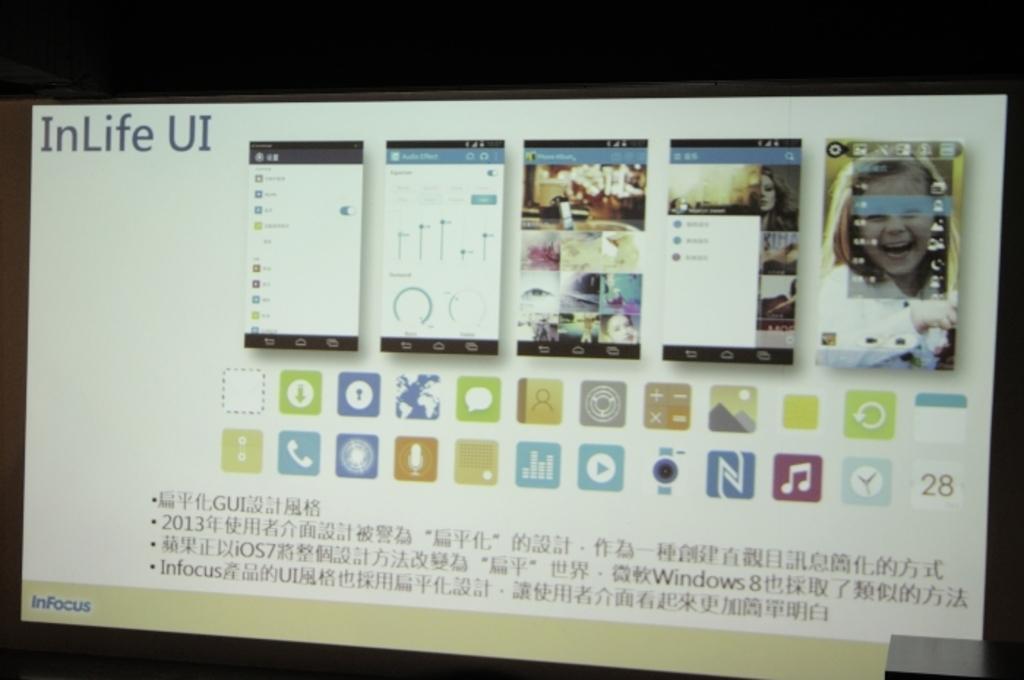In one or two sentences, can you explain what this image depicts? In this image, we can see a screen. Here we can see mobile screenshots, some icons, text, images. 